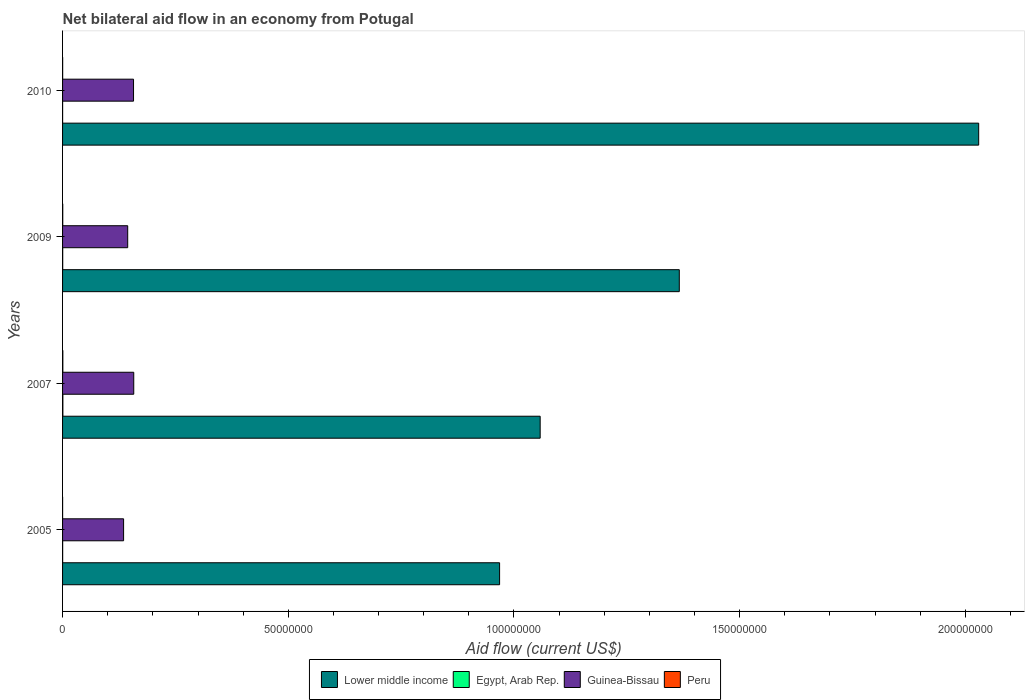How many groups of bars are there?
Offer a very short reply. 4. Are the number of bars per tick equal to the number of legend labels?
Your answer should be compact. Yes. What is the label of the 1st group of bars from the top?
Give a very brief answer. 2010. In how many cases, is the number of bars for a given year not equal to the number of legend labels?
Give a very brief answer. 0. Across all years, what is the maximum net bilateral aid flow in Guinea-Bissau?
Make the answer very short. 1.58e+07. Across all years, what is the minimum net bilateral aid flow in Egypt, Arab Rep.?
Offer a terse response. 10000. In which year was the net bilateral aid flow in Lower middle income maximum?
Provide a succinct answer. 2010. What is the total net bilateral aid flow in Peru in the graph?
Keep it short and to the point. 1.30e+05. What is the difference between the net bilateral aid flow in Egypt, Arab Rep. in 2007 and that in 2010?
Your answer should be compact. 6.00e+04. What is the difference between the net bilateral aid flow in Guinea-Bissau in 2010 and the net bilateral aid flow in Egypt, Arab Rep. in 2007?
Ensure brevity in your answer.  1.56e+07. What is the average net bilateral aid flow in Peru per year?
Your answer should be very brief. 3.25e+04. In the year 2007, what is the difference between the net bilateral aid flow in Egypt, Arab Rep. and net bilateral aid flow in Lower middle income?
Your response must be concise. -1.06e+08. What is the ratio of the net bilateral aid flow in Peru in 2005 to that in 2007?
Ensure brevity in your answer.  0.17. Is the net bilateral aid flow in Lower middle income in 2009 less than that in 2010?
Give a very brief answer. Yes. Is the difference between the net bilateral aid flow in Egypt, Arab Rep. in 2007 and 2009 greater than the difference between the net bilateral aid flow in Lower middle income in 2007 and 2009?
Provide a succinct answer. Yes. What is the difference between the highest and the second highest net bilateral aid flow in Lower middle income?
Offer a very short reply. 6.63e+07. In how many years, is the net bilateral aid flow in Guinea-Bissau greater than the average net bilateral aid flow in Guinea-Bissau taken over all years?
Your response must be concise. 2. Is the sum of the net bilateral aid flow in Egypt, Arab Rep. in 2007 and 2009 greater than the maximum net bilateral aid flow in Lower middle income across all years?
Your answer should be very brief. No. Is it the case that in every year, the sum of the net bilateral aid flow in Lower middle income and net bilateral aid flow in Peru is greater than the sum of net bilateral aid flow in Guinea-Bissau and net bilateral aid flow in Egypt, Arab Rep.?
Your answer should be compact. No. What does the 2nd bar from the top in 2010 represents?
Your answer should be very brief. Guinea-Bissau. What does the 2nd bar from the bottom in 2005 represents?
Your answer should be compact. Egypt, Arab Rep. Are all the bars in the graph horizontal?
Your answer should be very brief. Yes. Does the graph contain any zero values?
Provide a succinct answer. No. How many legend labels are there?
Provide a succinct answer. 4. How are the legend labels stacked?
Make the answer very short. Horizontal. What is the title of the graph?
Keep it short and to the point. Net bilateral aid flow in an economy from Potugal. What is the label or title of the X-axis?
Offer a very short reply. Aid flow (current US$). What is the label or title of the Y-axis?
Provide a short and direct response. Years. What is the Aid flow (current US$) of Lower middle income in 2005?
Your answer should be very brief. 9.68e+07. What is the Aid flow (current US$) of Egypt, Arab Rep. in 2005?
Your answer should be compact. 2.00e+04. What is the Aid flow (current US$) in Guinea-Bissau in 2005?
Give a very brief answer. 1.35e+07. What is the Aid flow (current US$) in Peru in 2005?
Provide a succinct answer. 10000. What is the Aid flow (current US$) in Lower middle income in 2007?
Make the answer very short. 1.06e+08. What is the Aid flow (current US$) of Guinea-Bissau in 2007?
Give a very brief answer. 1.58e+07. What is the Aid flow (current US$) of Peru in 2007?
Make the answer very short. 6.00e+04. What is the Aid flow (current US$) of Lower middle income in 2009?
Offer a very short reply. 1.37e+08. What is the Aid flow (current US$) in Egypt, Arab Rep. in 2009?
Provide a short and direct response. 3.00e+04. What is the Aid flow (current US$) in Guinea-Bissau in 2009?
Your response must be concise. 1.44e+07. What is the Aid flow (current US$) in Lower middle income in 2010?
Your response must be concise. 2.03e+08. What is the Aid flow (current US$) in Egypt, Arab Rep. in 2010?
Your answer should be compact. 10000. What is the Aid flow (current US$) of Guinea-Bissau in 2010?
Your response must be concise. 1.57e+07. Across all years, what is the maximum Aid flow (current US$) in Lower middle income?
Keep it short and to the point. 2.03e+08. Across all years, what is the maximum Aid flow (current US$) of Egypt, Arab Rep.?
Offer a terse response. 7.00e+04. Across all years, what is the maximum Aid flow (current US$) of Guinea-Bissau?
Offer a very short reply. 1.58e+07. Across all years, what is the maximum Aid flow (current US$) of Peru?
Your answer should be compact. 6.00e+04. Across all years, what is the minimum Aid flow (current US$) in Lower middle income?
Offer a very short reply. 9.68e+07. Across all years, what is the minimum Aid flow (current US$) of Egypt, Arab Rep.?
Your response must be concise. 10000. Across all years, what is the minimum Aid flow (current US$) in Guinea-Bissau?
Offer a very short reply. 1.35e+07. Across all years, what is the minimum Aid flow (current US$) in Peru?
Ensure brevity in your answer.  10000. What is the total Aid flow (current US$) in Lower middle income in the graph?
Ensure brevity in your answer.  5.42e+08. What is the total Aid flow (current US$) in Egypt, Arab Rep. in the graph?
Provide a short and direct response. 1.30e+05. What is the total Aid flow (current US$) in Guinea-Bissau in the graph?
Give a very brief answer. 5.94e+07. What is the total Aid flow (current US$) in Peru in the graph?
Your answer should be very brief. 1.30e+05. What is the difference between the Aid flow (current US$) in Lower middle income in 2005 and that in 2007?
Provide a succinct answer. -8.99e+06. What is the difference between the Aid flow (current US$) in Egypt, Arab Rep. in 2005 and that in 2007?
Your answer should be compact. -5.00e+04. What is the difference between the Aid flow (current US$) in Guinea-Bissau in 2005 and that in 2007?
Offer a terse response. -2.25e+06. What is the difference between the Aid flow (current US$) of Peru in 2005 and that in 2007?
Make the answer very short. -5.00e+04. What is the difference between the Aid flow (current US$) in Lower middle income in 2005 and that in 2009?
Your answer should be very brief. -3.98e+07. What is the difference between the Aid flow (current US$) of Egypt, Arab Rep. in 2005 and that in 2009?
Make the answer very short. -10000. What is the difference between the Aid flow (current US$) of Guinea-Bissau in 2005 and that in 2009?
Your response must be concise. -9.10e+05. What is the difference between the Aid flow (current US$) of Peru in 2005 and that in 2009?
Keep it short and to the point. -3.00e+04. What is the difference between the Aid flow (current US$) in Lower middle income in 2005 and that in 2010?
Make the answer very short. -1.06e+08. What is the difference between the Aid flow (current US$) of Guinea-Bissau in 2005 and that in 2010?
Offer a very short reply. -2.20e+06. What is the difference between the Aid flow (current US$) in Peru in 2005 and that in 2010?
Your answer should be very brief. -10000. What is the difference between the Aid flow (current US$) in Lower middle income in 2007 and that in 2009?
Your response must be concise. -3.08e+07. What is the difference between the Aid flow (current US$) in Guinea-Bissau in 2007 and that in 2009?
Ensure brevity in your answer.  1.34e+06. What is the difference between the Aid flow (current US$) of Lower middle income in 2007 and that in 2010?
Provide a succinct answer. -9.71e+07. What is the difference between the Aid flow (current US$) of Egypt, Arab Rep. in 2007 and that in 2010?
Give a very brief answer. 6.00e+04. What is the difference between the Aid flow (current US$) of Guinea-Bissau in 2007 and that in 2010?
Give a very brief answer. 5.00e+04. What is the difference between the Aid flow (current US$) of Lower middle income in 2009 and that in 2010?
Your answer should be very brief. -6.63e+07. What is the difference between the Aid flow (current US$) of Guinea-Bissau in 2009 and that in 2010?
Your response must be concise. -1.29e+06. What is the difference between the Aid flow (current US$) in Peru in 2009 and that in 2010?
Provide a succinct answer. 2.00e+04. What is the difference between the Aid flow (current US$) in Lower middle income in 2005 and the Aid flow (current US$) in Egypt, Arab Rep. in 2007?
Provide a succinct answer. 9.67e+07. What is the difference between the Aid flow (current US$) of Lower middle income in 2005 and the Aid flow (current US$) of Guinea-Bissau in 2007?
Provide a short and direct response. 8.10e+07. What is the difference between the Aid flow (current US$) in Lower middle income in 2005 and the Aid flow (current US$) in Peru in 2007?
Your answer should be very brief. 9.68e+07. What is the difference between the Aid flow (current US$) of Egypt, Arab Rep. in 2005 and the Aid flow (current US$) of Guinea-Bissau in 2007?
Your response must be concise. -1.58e+07. What is the difference between the Aid flow (current US$) of Egypt, Arab Rep. in 2005 and the Aid flow (current US$) of Peru in 2007?
Offer a terse response. -4.00e+04. What is the difference between the Aid flow (current US$) in Guinea-Bissau in 2005 and the Aid flow (current US$) in Peru in 2007?
Ensure brevity in your answer.  1.35e+07. What is the difference between the Aid flow (current US$) in Lower middle income in 2005 and the Aid flow (current US$) in Egypt, Arab Rep. in 2009?
Your response must be concise. 9.68e+07. What is the difference between the Aid flow (current US$) in Lower middle income in 2005 and the Aid flow (current US$) in Guinea-Bissau in 2009?
Offer a terse response. 8.24e+07. What is the difference between the Aid flow (current US$) in Lower middle income in 2005 and the Aid flow (current US$) in Peru in 2009?
Offer a terse response. 9.68e+07. What is the difference between the Aid flow (current US$) in Egypt, Arab Rep. in 2005 and the Aid flow (current US$) in Guinea-Bissau in 2009?
Provide a short and direct response. -1.44e+07. What is the difference between the Aid flow (current US$) in Guinea-Bissau in 2005 and the Aid flow (current US$) in Peru in 2009?
Keep it short and to the point. 1.35e+07. What is the difference between the Aid flow (current US$) in Lower middle income in 2005 and the Aid flow (current US$) in Egypt, Arab Rep. in 2010?
Provide a succinct answer. 9.68e+07. What is the difference between the Aid flow (current US$) of Lower middle income in 2005 and the Aid flow (current US$) of Guinea-Bissau in 2010?
Make the answer very short. 8.11e+07. What is the difference between the Aid flow (current US$) of Lower middle income in 2005 and the Aid flow (current US$) of Peru in 2010?
Provide a short and direct response. 9.68e+07. What is the difference between the Aid flow (current US$) of Egypt, Arab Rep. in 2005 and the Aid flow (current US$) of Guinea-Bissau in 2010?
Your answer should be very brief. -1.57e+07. What is the difference between the Aid flow (current US$) of Egypt, Arab Rep. in 2005 and the Aid flow (current US$) of Peru in 2010?
Your response must be concise. 0. What is the difference between the Aid flow (current US$) in Guinea-Bissau in 2005 and the Aid flow (current US$) in Peru in 2010?
Ensure brevity in your answer.  1.35e+07. What is the difference between the Aid flow (current US$) of Lower middle income in 2007 and the Aid flow (current US$) of Egypt, Arab Rep. in 2009?
Ensure brevity in your answer.  1.06e+08. What is the difference between the Aid flow (current US$) in Lower middle income in 2007 and the Aid flow (current US$) in Guinea-Bissau in 2009?
Your answer should be very brief. 9.14e+07. What is the difference between the Aid flow (current US$) in Lower middle income in 2007 and the Aid flow (current US$) in Peru in 2009?
Offer a terse response. 1.06e+08. What is the difference between the Aid flow (current US$) in Egypt, Arab Rep. in 2007 and the Aid flow (current US$) in Guinea-Bissau in 2009?
Offer a very short reply. -1.44e+07. What is the difference between the Aid flow (current US$) of Egypt, Arab Rep. in 2007 and the Aid flow (current US$) of Peru in 2009?
Your response must be concise. 3.00e+04. What is the difference between the Aid flow (current US$) of Guinea-Bissau in 2007 and the Aid flow (current US$) of Peru in 2009?
Offer a terse response. 1.57e+07. What is the difference between the Aid flow (current US$) in Lower middle income in 2007 and the Aid flow (current US$) in Egypt, Arab Rep. in 2010?
Your response must be concise. 1.06e+08. What is the difference between the Aid flow (current US$) of Lower middle income in 2007 and the Aid flow (current US$) of Guinea-Bissau in 2010?
Make the answer very short. 9.01e+07. What is the difference between the Aid flow (current US$) of Lower middle income in 2007 and the Aid flow (current US$) of Peru in 2010?
Provide a short and direct response. 1.06e+08. What is the difference between the Aid flow (current US$) in Egypt, Arab Rep. in 2007 and the Aid flow (current US$) in Guinea-Bissau in 2010?
Provide a short and direct response. -1.56e+07. What is the difference between the Aid flow (current US$) of Guinea-Bissau in 2007 and the Aid flow (current US$) of Peru in 2010?
Offer a very short reply. 1.58e+07. What is the difference between the Aid flow (current US$) of Lower middle income in 2009 and the Aid flow (current US$) of Egypt, Arab Rep. in 2010?
Ensure brevity in your answer.  1.37e+08. What is the difference between the Aid flow (current US$) of Lower middle income in 2009 and the Aid flow (current US$) of Guinea-Bissau in 2010?
Offer a very short reply. 1.21e+08. What is the difference between the Aid flow (current US$) in Lower middle income in 2009 and the Aid flow (current US$) in Peru in 2010?
Offer a very short reply. 1.37e+08. What is the difference between the Aid flow (current US$) of Egypt, Arab Rep. in 2009 and the Aid flow (current US$) of Guinea-Bissau in 2010?
Give a very brief answer. -1.57e+07. What is the difference between the Aid flow (current US$) in Guinea-Bissau in 2009 and the Aid flow (current US$) in Peru in 2010?
Your response must be concise. 1.44e+07. What is the average Aid flow (current US$) in Lower middle income per year?
Give a very brief answer. 1.36e+08. What is the average Aid flow (current US$) of Egypt, Arab Rep. per year?
Your answer should be compact. 3.25e+04. What is the average Aid flow (current US$) of Guinea-Bissau per year?
Make the answer very short. 1.49e+07. What is the average Aid flow (current US$) of Peru per year?
Provide a succinct answer. 3.25e+04. In the year 2005, what is the difference between the Aid flow (current US$) in Lower middle income and Aid flow (current US$) in Egypt, Arab Rep.?
Offer a very short reply. 9.68e+07. In the year 2005, what is the difference between the Aid flow (current US$) in Lower middle income and Aid flow (current US$) in Guinea-Bissau?
Ensure brevity in your answer.  8.33e+07. In the year 2005, what is the difference between the Aid flow (current US$) of Lower middle income and Aid flow (current US$) of Peru?
Your answer should be very brief. 9.68e+07. In the year 2005, what is the difference between the Aid flow (current US$) of Egypt, Arab Rep. and Aid flow (current US$) of Guinea-Bissau?
Your response must be concise. -1.35e+07. In the year 2005, what is the difference between the Aid flow (current US$) in Egypt, Arab Rep. and Aid flow (current US$) in Peru?
Keep it short and to the point. 10000. In the year 2005, what is the difference between the Aid flow (current US$) of Guinea-Bissau and Aid flow (current US$) of Peru?
Ensure brevity in your answer.  1.35e+07. In the year 2007, what is the difference between the Aid flow (current US$) of Lower middle income and Aid flow (current US$) of Egypt, Arab Rep.?
Your answer should be very brief. 1.06e+08. In the year 2007, what is the difference between the Aid flow (current US$) in Lower middle income and Aid flow (current US$) in Guinea-Bissau?
Ensure brevity in your answer.  9.00e+07. In the year 2007, what is the difference between the Aid flow (current US$) of Lower middle income and Aid flow (current US$) of Peru?
Make the answer very short. 1.06e+08. In the year 2007, what is the difference between the Aid flow (current US$) in Egypt, Arab Rep. and Aid flow (current US$) in Guinea-Bissau?
Your answer should be very brief. -1.57e+07. In the year 2007, what is the difference between the Aid flow (current US$) of Egypt, Arab Rep. and Aid flow (current US$) of Peru?
Provide a succinct answer. 10000. In the year 2007, what is the difference between the Aid flow (current US$) of Guinea-Bissau and Aid flow (current US$) of Peru?
Offer a very short reply. 1.57e+07. In the year 2009, what is the difference between the Aid flow (current US$) in Lower middle income and Aid flow (current US$) in Egypt, Arab Rep.?
Make the answer very short. 1.37e+08. In the year 2009, what is the difference between the Aid flow (current US$) in Lower middle income and Aid flow (current US$) in Guinea-Bissau?
Provide a succinct answer. 1.22e+08. In the year 2009, what is the difference between the Aid flow (current US$) of Lower middle income and Aid flow (current US$) of Peru?
Provide a succinct answer. 1.37e+08. In the year 2009, what is the difference between the Aid flow (current US$) of Egypt, Arab Rep. and Aid flow (current US$) of Guinea-Bissau?
Your answer should be very brief. -1.44e+07. In the year 2009, what is the difference between the Aid flow (current US$) in Guinea-Bissau and Aid flow (current US$) in Peru?
Keep it short and to the point. 1.44e+07. In the year 2010, what is the difference between the Aid flow (current US$) of Lower middle income and Aid flow (current US$) of Egypt, Arab Rep.?
Make the answer very short. 2.03e+08. In the year 2010, what is the difference between the Aid flow (current US$) in Lower middle income and Aid flow (current US$) in Guinea-Bissau?
Offer a very short reply. 1.87e+08. In the year 2010, what is the difference between the Aid flow (current US$) of Lower middle income and Aid flow (current US$) of Peru?
Offer a very short reply. 2.03e+08. In the year 2010, what is the difference between the Aid flow (current US$) of Egypt, Arab Rep. and Aid flow (current US$) of Guinea-Bissau?
Offer a terse response. -1.57e+07. In the year 2010, what is the difference between the Aid flow (current US$) of Guinea-Bissau and Aid flow (current US$) of Peru?
Your response must be concise. 1.57e+07. What is the ratio of the Aid flow (current US$) in Lower middle income in 2005 to that in 2007?
Your answer should be compact. 0.92. What is the ratio of the Aid flow (current US$) of Egypt, Arab Rep. in 2005 to that in 2007?
Your answer should be very brief. 0.29. What is the ratio of the Aid flow (current US$) of Guinea-Bissau in 2005 to that in 2007?
Give a very brief answer. 0.86. What is the ratio of the Aid flow (current US$) of Lower middle income in 2005 to that in 2009?
Provide a succinct answer. 0.71. What is the ratio of the Aid flow (current US$) of Guinea-Bissau in 2005 to that in 2009?
Offer a terse response. 0.94. What is the ratio of the Aid flow (current US$) of Lower middle income in 2005 to that in 2010?
Give a very brief answer. 0.48. What is the ratio of the Aid flow (current US$) in Egypt, Arab Rep. in 2005 to that in 2010?
Offer a very short reply. 2. What is the ratio of the Aid flow (current US$) of Guinea-Bissau in 2005 to that in 2010?
Provide a succinct answer. 0.86. What is the ratio of the Aid flow (current US$) in Lower middle income in 2007 to that in 2009?
Ensure brevity in your answer.  0.77. What is the ratio of the Aid flow (current US$) in Egypt, Arab Rep. in 2007 to that in 2009?
Keep it short and to the point. 2.33. What is the ratio of the Aid flow (current US$) in Guinea-Bissau in 2007 to that in 2009?
Provide a short and direct response. 1.09. What is the ratio of the Aid flow (current US$) in Peru in 2007 to that in 2009?
Make the answer very short. 1.5. What is the ratio of the Aid flow (current US$) of Lower middle income in 2007 to that in 2010?
Offer a terse response. 0.52. What is the ratio of the Aid flow (current US$) of Egypt, Arab Rep. in 2007 to that in 2010?
Make the answer very short. 7. What is the ratio of the Aid flow (current US$) of Peru in 2007 to that in 2010?
Offer a very short reply. 3. What is the ratio of the Aid flow (current US$) in Lower middle income in 2009 to that in 2010?
Give a very brief answer. 0.67. What is the ratio of the Aid flow (current US$) in Guinea-Bissau in 2009 to that in 2010?
Your response must be concise. 0.92. What is the difference between the highest and the second highest Aid flow (current US$) in Lower middle income?
Offer a terse response. 6.63e+07. What is the difference between the highest and the lowest Aid flow (current US$) of Lower middle income?
Offer a very short reply. 1.06e+08. What is the difference between the highest and the lowest Aid flow (current US$) of Guinea-Bissau?
Your answer should be very brief. 2.25e+06. What is the difference between the highest and the lowest Aid flow (current US$) of Peru?
Provide a short and direct response. 5.00e+04. 